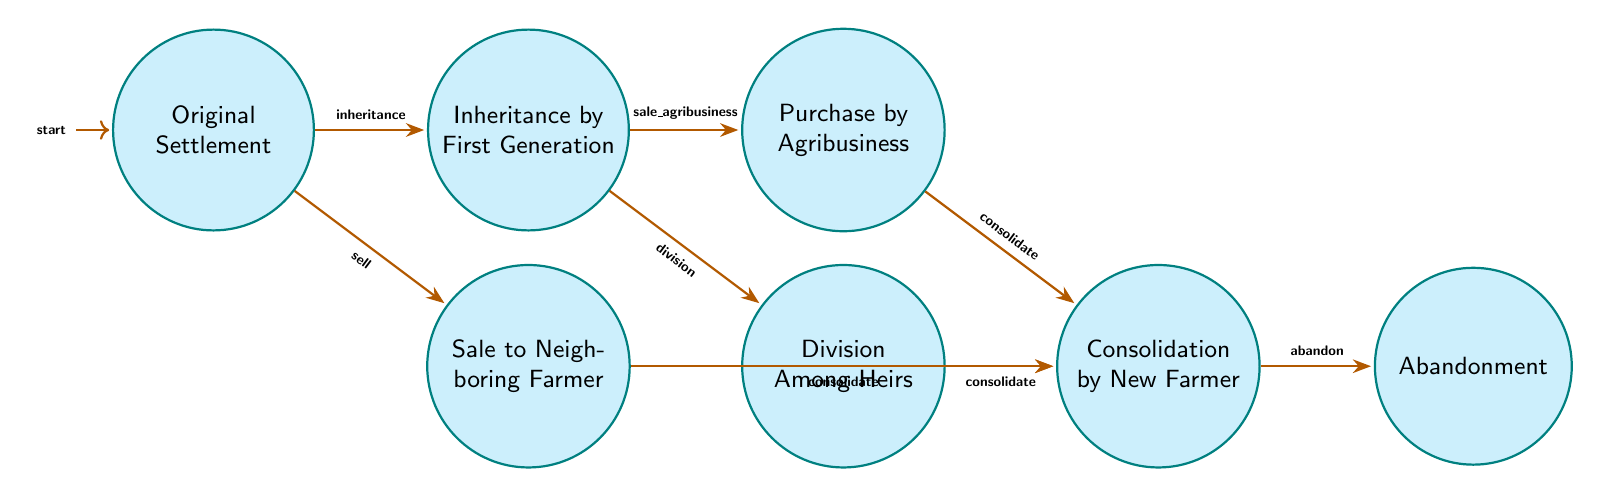What is the first state in the diagram? The first state is indicated by the initial node label which is "Original Settlement".
Answer: Original Settlement How many states are in the diagram? By counting the nodes listed, there are 7 distinct states in the diagram.
Answer: 7 Which state comes after "Inheritance by First Generation" when the input is "sale_agribusiness"? Following the transition labeled "sale_agribusiness" from "Inheritance by First Generation", the next state is "Purchase by Agribusiness".
Answer: Purchase by Agribusiness What transition leads from "Sale to Neighboring Farmer" to another state? The transition encoded as "consolidate" is the edge that connects "Sale to Neighboring Farmer" to the state "Consolidation by New Farmer".
Answer: consolidate What is the final state that can be reached from "Consolidation by New Farmer"? The only transition from "Consolidation by New Farmer" is labeled "abandon", which leads directly to the final state "Abandonment".
Answer: Abandonment Which transition can lead to "Division Among Heirs"? The "division" input transitioning from "Inheritance by First Generation" is the path that leads to "Division Among Heirs".
Answer: division If the state is "Abandonment", what was the previous state? The state must have transitioned from "Consolidation by New Farmer", as that is the only state connecting to "Abandonment" through the "abandon" input.
Answer: Consolidation by New Farmer What are the two possible transitions from the "Original Settlement" state? The two transitions are "inheritance" leading to "Inheritance by First Generation" and "sell" leading to "Sale to Neighboring Farmer".
Answer: inheritance, sell What type of state leads to "Consolidation by New Farmer"? The state "Consolidation by New Farmer" can be reached from three states: "Sale to Neighboring Farmer", "Purchase by Agribusiness", and "Division Among Heirs", indicating it's a consolidation phase.
Answer: Sale to Neighboring Farmer, Purchase by Agribusiness, Division Among Heirs 